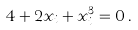<formula> <loc_0><loc_0><loc_500><loc_500>4 + 2 x _ { i } + x _ { i } ^ { 3 } = 0 \, .</formula> 